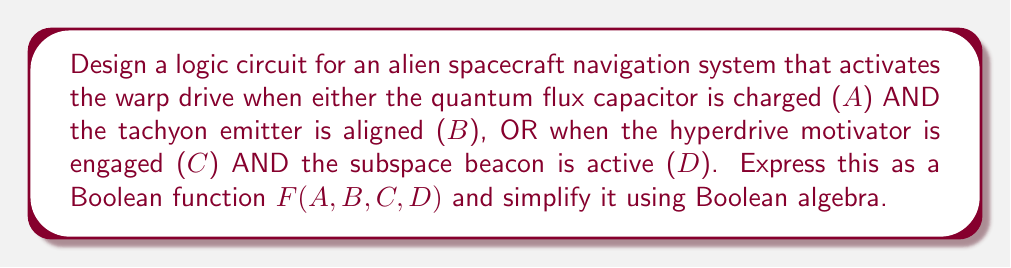Provide a solution to this math problem. 1) First, let's express the given conditions as a Boolean function:
   $F(A,B,C,D) = (A \cdot B) + (C \cdot D)$

2) This function is already in its simplest form, known as the Sum of Products (SOP) form. It consists of two product terms added together.

3) We can verify this by applying the distributive law:
   $(A \cdot B) + (C \cdot D) = (A + C) \cdot (A + D) \cdot (B + C) \cdot (B + D)$

4) Expanding this would give us:
   $AB + AD + BC + BD$

5) However, $AD$ and $BC$ are not in our original function, so we can't simplify further.

6) The logic circuit for this function would consist of:
   - Two AND gates (for $A \cdot B$ and $C \cdot D$)
   - One OR gate (to combine the results of the AND gates)

[asy]
unitsize(1cm);

pair A = (0,3), B = (0,2), C = (0,1), D = (0,0);
pair AND1 = (2,2.5), AND2 = (2,0.5), OR = (4,1.5);
pair OUT = (6,1.5);

draw(A--AND1--OR--OUT);
draw(B--AND1);
draw(C--AND2--OR);
draw(D--AND2);

label("A", A, W);
label("B", B, W);
label("C", C, W);
label("D", D, W);
label("AND", AND1, E);
label("AND", AND2, E);
label("OR", OR, E);
label("F", OUT, E);

draw(circle(AND1, 0.5));
draw(circle(AND2, 0.5));
draw(circle(OR, 0.5));
[/asy]
Answer: $F(A,B,C,D) = (A \cdot B) + (C \cdot D)$ 